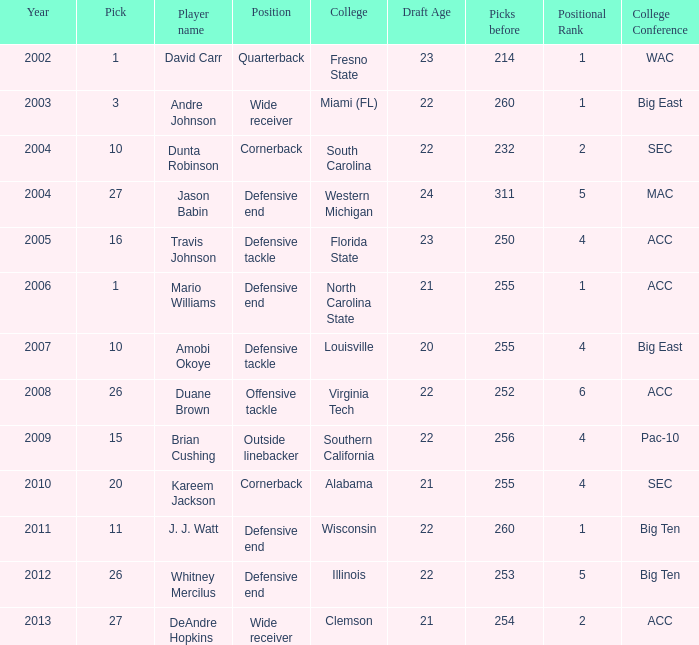What pick was mario williams before 2006? None. 